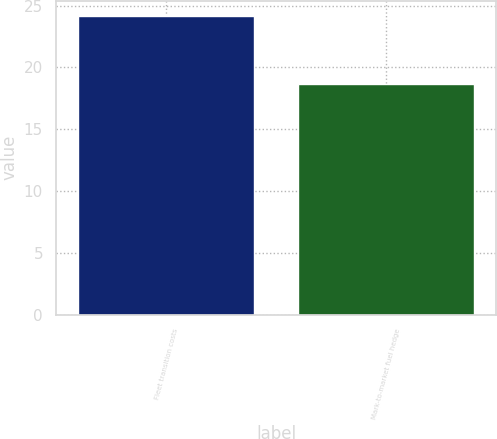Convert chart. <chart><loc_0><loc_0><loc_500><loc_500><bar_chart><fcel>Fleet transition costs<fcel>Mark-to-market fuel hedge<nl><fcel>24.2<fcel>18.7<nl></chart> 